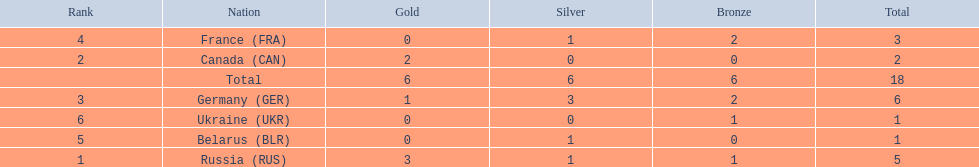Which countries had one or more gold medals? Russia (RUS), Canada (CAN), Germany (GER). Of these countries, which had at least one silver medal? Russia (RUS), Germany (GER). Of the remaining countries, who had more medals overall? Germany (GER). 